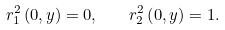Convert formula to latex. <formula><loc_0><loc_0><loc_500><loc_500>r _ { 1 } ^ { 2 } \left ( 0 , y \right ) = 0 , \quad r _ { 2 } ^ { 2 } \left ( 0 , y \right ) = 1 .</formula> 